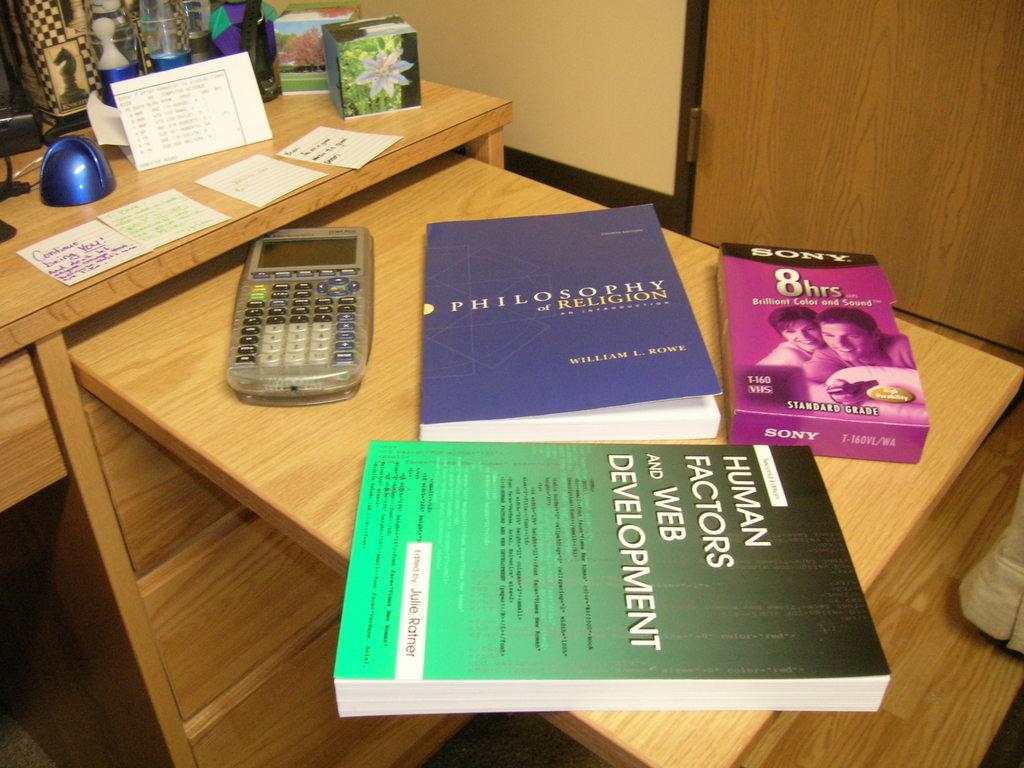What type of furniture is present in the image? There is a table in the image. What items can be seen on the table? There are books, a calculator, cards, a box, and a glass bottle on the table. Is there any symbol or marking on the table? Yes, there is a chess coin symbol on the table. What additional feature is present below the table? There are racks below the table. Can you tell me how many bees are sitting on the table in the image? There are no bees present in the image; the table only contains books, a calculator, cards, a box, a glass bottle, and a chess coin symbol. 